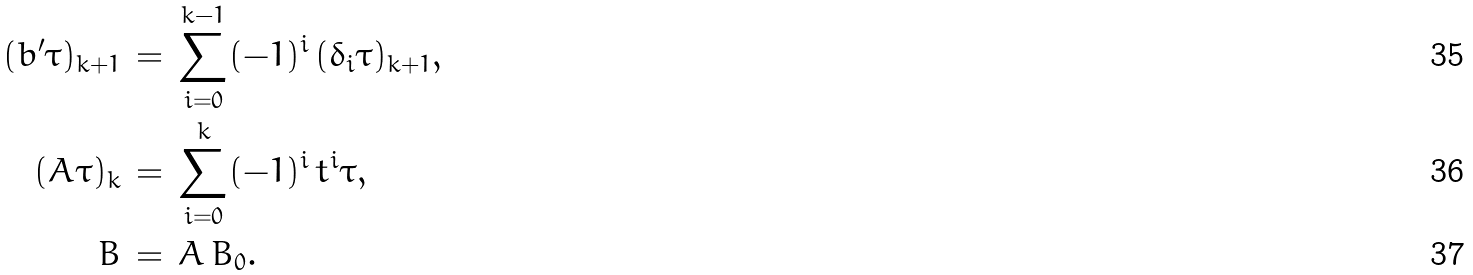Convert formula to latex. <formula><loc_0><loc_0><loc_500><loc_500>( b ^ { \prime } \tau ) _ { k + 1 } \, & = \, \sum _ { i = 0 } ^ { k - 1 } ( - 1 ) ^ { i } \, ( \delta _ { i } \tau ) _ { k + 1 } , \\ ( A \tau ) _ { k } \, & = \, \sum _ { i = 0 } ^ { k } ( - 1 ) ^ { i } \, t ^ { i } \tau , \\ B \, & = \, A \, B _ { 0 } .</formula> 